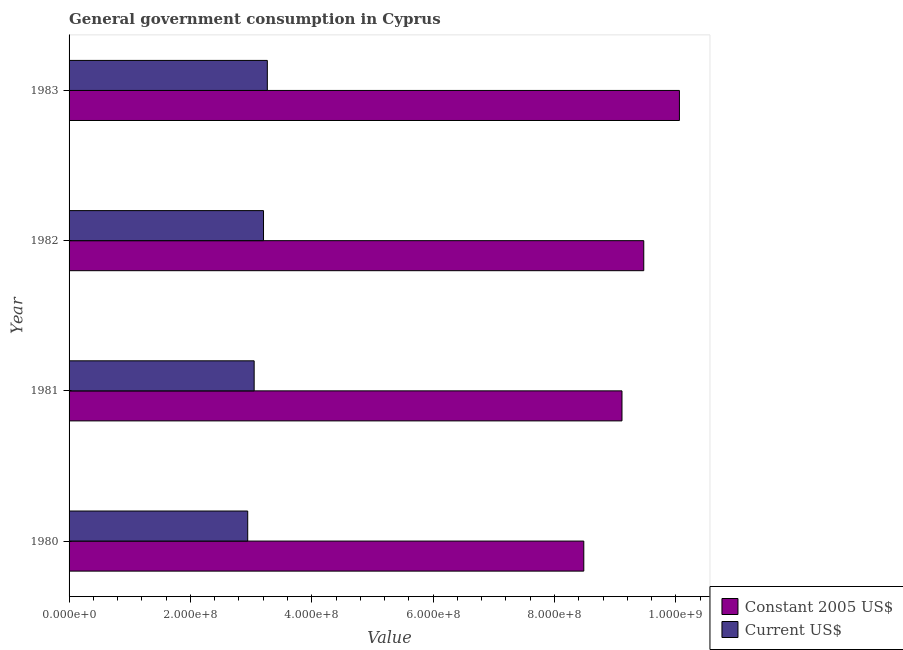How many different coloured bars are there?
Your answer should be very brief. 2. How many groups of bars are there?
Provide a succinct answer. 4. Are the number of bars per tick equal to the number of legend labels?
Keep it short and to the point. Yes. How many bars are there on the 1st tick from the top?
Provide a succinct answer. 2. What is the value consumed in constant 2005 us$ in 1983?
Your response must be concise. 1.01e+09. Across all years, what is the maximum value consumed in constant 2005 us$?
Give a very brief answer. 1.01e+09. Across all years, what is the minimum value consumed in constant 2005 us$?
Offer a very short reply. 8.48e+08. In which year was the value consumed in current us$ maximum?
Offer a very short reply. 1983. What is the total value consumed in constant 2005 us$ in the graph?
Provide a succinct answer. 3.71e+09. What is the difference between the value consumed in constant 2005 us$ in 1981 and that in 1982?
Keep it short and to the point. -3.59e+07. What is the difference between the value consumed in constant 2005 us$ in 1982 and the value consumed in current us$ in 1983?
Your answer should be very brief. 6.20e+08. What is the average value consumed in current us$ per year?
Provide a succinct answer. 3.12e+08. In the year 1980, what is the difference between the value consumed in current us$ and value consumed in constant 2005 us$?
Provide a succinct answer. -5.54e+08. In how many years, is the value consumed in current us$ greater than 200000000 ?
Give a very brief answer. 4. What is the ratio of the value consumed in current us$ in 1982 to that in 1983?
Offer a very short reply. 0.98. What is the difference between the highest and the second highest value consumed in constant 2005 us$?
Your answer should be compact. 5.88e+07. What is the difference between the highest and the lowest value consumed in constant 2005 us$?
Keep it short and to the point. 1.58e+08. Is the sum of the value consumed in constant 2005 us$ in 1980 and 1982 greater than the maximum value consumed in current us$ across all years?
Ensure brevity in your answer.  Yes. What does the 2nd bar from the top in 1981 represents?
Make the answer very short. Constant 2005 US$. What does the 2nd bar from the bottom in 1983 represents?
Make the answer very short. Current US$. How many bars are there?
Give a very brief answer. 8. How many years are there in the graph?
Your answer should be compact. 4. Are the values on the major ticks of X-axis written in scientific E-notation?
Give a very brief answer. Yes. Does the graph contain any zero values?
Provide a short and direct response. No. Where does the legend appear in the graph?
Your answer should be very brief. Bottom right. How many legend labels are there?
Ensure brevity in your answer.  2. How are the legend labels stacked?
Keep it short and to the point. Vertical. What is the title of the graph?
Keep it short and to the point. General government consumption in Cyprus. Does "constant 2005 US$" appear as one of the legend labels in the graph?
Make the answer very short. No. What is the label or title of the X-axis?
Ensure brevity in your answer.  Value. What is the Value in Constant 2005 US$ in 1980?
Ensure brevity in your answer.  8.48e+08. What is the Value of Current US$ in 1980?
Offer a very short reply. 2.94e+08. What is the Value of Constant 2005 US$ in 1981?
Provide a succinct answer. 9.11e+08. What is the Value of Current US$ in 1981?
Give a very brief answer. 3.05e+08. What is the Value in Constant 2005 US$ in 1982?
Offer a terse response. 9.47e+08. What is the Value in Current US$ in 1982?
Ensure brevity in your answer.  3.20e+08. What is the Value of Constant 2005 US$ in 1983?
Offer a very short reply. 1.01e+09. What is the Value in Current US$ in 1983?
Provide a short and direct response. 3.27e+08. Across all years, what is the maximum Value of Constant 2005 US$?
Keep it short and to the point. 1.01e+09. Across all years, what is the maximum Value of Current US$?
Offer a very short reply. 3.27e+08. Across all years, what is the minimum Value in Constant 2005 US$?
Provide a succinct answer. 8.48e+08. Across all years, what is the minimum Value in Current US$?
Your response must be concise. 2.94e+08. What is the total Value of Constant 2005 US$ in the graph?
Offer a terse response. 3.71e+09. What is the total Value in Current US$ in the graph?
Make the answer very short. 1.25e+09. What is the difference between the Value in Constant 2005 US$ in 1980 and that in 1981?
Keep it short and to the point. -6.29e+07. What is the difference between the Value of Current US$ in 1980 and that in 1981?
Provide a short and direct response. -1.06e+07. What is the difference between the Value of Constant 2005 US$ in 1980 and that in 1982?
Your answer should be compact. -9.88e+07. What is the difference between the Value in Current US$ in 1980 and that in 1982?
Keep it short and to the point. -2.60e+07. What is the difference between the Value in Constant 2005 US$ in 1980 and that in 1983?
Provide a short and direct response. -1.58e+08. What is the difference between the Value of Current US$ in 1980 and that in 1983?
Provide a short and direct response. -3.23e+07. What is the difference between the Value in Constant 2005 US$ in 1981 and that in 1982?
Ensure brevity in your answer.  -3.59e+07. What is the difference between the Value of Current US$ in 1981 and that in 1982?
Ensure brevity in your answer.  -1.54e+07. What is the difference between the Value of Constant 2005 US$ in 1981 and that in 1983?
Make the answer very short. -9.47e+07. What is the difference between the Value of Current US$ in 1981 and that in 1983?
Keep it short and to the point. -2.17e+07. What is the difference between the Value in Constant 2005 US$ in 1982 and that in 1983?
Ensure brevity in your answer.  -5.88e+07. What is the difference between the Value in Current US$ in 1982 and that in 1983?
Your answer should be compact. -6.26e+06. What is the difference between the Value in Constant 2005 US$ in 1980 and the Value in Current US$ in 1981?
Make the answer very short. 5.43e+08. What is the difference between the Value in Constant 2005 US$ in 1980 and the Value in Current US$ in 1982?
Offer a terse response. 5.28e+08. What is the difference between the Value of Constant 2005 US$ in 1980 and the Value of Current US$ in 1983?
Your answer should be very brief. 5.22e+08. What is the difference between the Value in Constant 2005 US$ in 1981 and the Value in Current US$ in 1982?
Offer a very short reply. 5.91e+08. What is the difference between the Value in Constant 2005 US$ in 1981 and the Value in Current US$ in 1983?
Your answer should be very brief. 5.84e+08. What is the difference between the Value of Constant 2005 US$ in 1982 and the Value of Current US$ in 1983?
Ensure brevity in your answer.  6.20e+08. What is the average Value in Constant 2005 US$ per year?
Provide a succinct answer. 9.28e+08. What is the average Value of Current US$ per year?
Provide a short and direct response. 3.12e+08. In the year 1980, what is the difference between the Value in Constant 2005 US$ and Value in Current US$?
Provide a succinct answer. 5.54e+08. In the year 1981, what is the difference between the Value of Constant 2005 US$ and Value of Current US$?
Give a very brief answer. 6.06e+08. In the year 1982, what is the difference between the Value of Constant 2005 US$ and Value of Current US$?
Offer a terse response. 6.27e+08. In the year 1983, what is the difference between the Value in Constant 2005 US$ and Value in Current US$?
Give a very brief answer. 6.79e+08. What is the ratio of the Value in Constant 2005 US$ in 1980 to that in 1981?
Give a very brief answer. 0.93. What is the ratio of the Value of Current US$ in 1980 to that in 1981?
Keep it short and to the point. 0.97. What is the ratio of the Value of Constant 2005 US$ in 1980 to that in 1982?
Keep it short and to the point. 0.9. What is the ratio of the Value of Current US$ in 1980 to that in 1982?
Keep it short and to the point. 0.92. What is the ratio of the Value of Constant 2005 US$ in 1980 to that in 1983?
Your answer should be very brief. 0.84. What is the ratio of the Value of Current US$ in 1980 to that in 1983?
Provide a short and direct response. 0.9. What is the ratio of the Value in Constant 2005 US$ in 1981 to that in 1982?
Your response must be concise. 0.96. What is the ratio of the Value of Current US$ in 1981 to that in 1982?
Your answer should be compact. 0.95. What is the ratio of the Value of Constant 2005 US$ in 1981 to that in 1983?
Offer a terse response. 0.91. What is the ratio of the Value in Current US$ in 1981 to that in 1983?
Provide a succinct answer. 0.93. What is the ratio of the Value of Constant 2005 US$ in 1982 to that in 1983?
Your answer should be compact. 0.94. What is the ratio of the Value in Current US$ in 1982 to that in 1983?
Offer a terse response. 0.98. What is the difference between the highest and the second highest Value in Constant 2005 US$?
Offer a very short reply. 5.88e+07. What is the difference between the highest and the second highest Value of Current US$?
Your answer should be very brief. 6.26e+06. What is the difference between the highest and the lowest Value in Constant 2005 US$?
Keep it short and to the point. 1.58e+08. What is the difference between the highest and the lowest Value in Current US$?
Provide a succinct answer. 3.23e+07. 